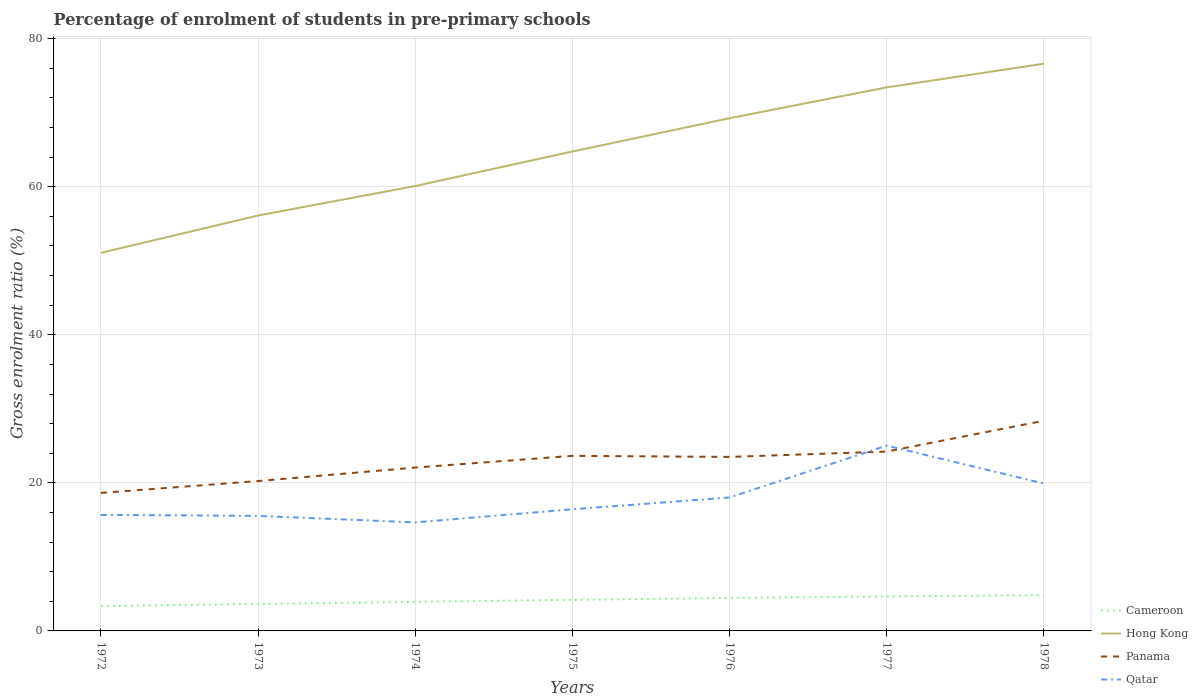How many different coloured lines are there?
Give a very brief answer. 4. Does the line corresponding to Cameroon intersect with the line corresponding to Qatar?
Your response must be concise. No. Is the number of lines equal to the number of legend labels?
Your answer should be compact. Yes. Across all years, what is the maximum percentage of students enrolled in pre-primary schools in Hong Kong?
Give a very brief answer. 51.07. In which year was the percentage of students enrolled in pre-primary schools in Panama maximum?
Your answer should be compact. 1972. What is the total percentage of students enrolled in pre-primary schools in Panama in the graph?
Your answer should be compact. -4.75. What is the difference between the highest and the second highest percentage of students enrolled in pre-primary schools in Cameroon?
Provide a short and direct response. 1.48. What is the difference between the highest and the lowest percentage of students enrolled in pre-primary schools in Qatar?
Ensure brevity in your answer.  3. How many lines are there?
Provide a succinct answer. 4. Are the values on the major ticks of Y-axis written in scientific E-notation?
Offer a terse response. No. Does the graph contain any zero values?
Your answer should be very brief. No. Does the graph contain grids?
Offer a terse response. Yes. How many legend labels are there?
Ensure brevity in your answer.  4. How are the legend labels stacked?
Your answer should be compact. Vertical. What is the title of the graph?
Your response must be concise. Percentage of enrolment of students in pre-primary schools. What is the label or title of the Y-axis?
Your response must be concise. Gross enrolment ratio (%). What is the Gross enrolment ratio (%) in Cameroon in 1972?
Make the answer very short. 3.35. What is the Gross enrolment ratio (%) of Hong Kong in 1972?
Offer a very short reply. 51.07. What is the Gross enrolment ratio (%) of Panama in 1972?
Give a very brief answer. 18.64. What is the Gross enrolment ratio (%) of Qatar in 1972?
Make the answer very short. 15.67. What is the Gross enrolment ratio (%) of Cameroon in 1973?
Your answer should be compact. 3.65. What is the Gross enrolment ratio (%) in Hong Kong in 1973?
Offer a terse response. 56.12. What is the Gross enrolment ratio (%) of Panama in 1973?
Keep it short and to the point. 20.25. What is the Gross enrolment ratio (%) in Qatar in 1973?
Your response must be concise. 15.54. What is the Gross enrolment ratio (%) in Cameroon in 1974?
Your answer should be compact. 3.93. What is the Gross enrolment ratio (%) of Hong Kong in 1974?
Make the answer very short. 60.1. What is the Gross enrolment ratio (%) of Panama in 1974?
Your response must be concise. 22.07. What is the Gross enrolment ratio (%) of Qatar in 1974?
Your answer should be compact. 14.66. What is the Gross enrolment ratio (%) in Cameroon in 1975?
Offer a very short reply. 4.19. What is the Gross enrolment ratio (%) of Hong Kong in 1975?
Your answer should be compact. 64.76. What is the Gross enrolment ratio (%) in Panama in 1975?
Provide a short and direct response. 23.65. What is the Gross enrolment ratio (%) of Qatar in 1975?
Ensure brevity in your answer.  16.43. What is the Gross enrolment ratio (%) in Cameroon in 1976?
Keep it short and to the point. 4.46. What is the Gross enrolment ratio (%) of Hong Kong in 1976?
Offer a very short reply. 69.26. What is the Gross enrolment ratio (%) of Panama in 1976?
Ensure brevity in your answer.  23.51. What is the Gross enrolment ratio (%) in Qatar in 1976?
Offer a terse response. 18.03. What is the Gross enrolment ratio (%) in Cameroon in 1977?
Your answer should be compact. 4.66. What is the Gross enrolment ratio (%) in Hong Kong in 1977?
Your answer should be compact. 73.43. What is the Gross enrolment ratio (%) of Panama in 1977?
Offer a terse response. 24.23. What is the Gross enrolment ratio (%) in Qatar in 1977?
Ensure brevity in your answer.  25.04. What is the Gross enrolment ratio (%) of Cameroon in 1978?
Provide a short and direct response. 4.83. What is the Gross enrolment ratio (%) in Hong Kong in 1978?
Make the answer very short. 76.62. What is the Gross enrolment ratio (%) of Panama in 1978?
Offer a very short reply. 28.4. What is the Gross enrolment ratio (%) in Qatar in 1978?
Offer a very short reply. 19.91. Across all years, what is the maximum Gross enrolment ratio (%) of Cameroon?
Your answer should be compact. 4.83. Across all years, what is the maximum Gross enrolment ratio (%) of Hong Kong?
Offer a terse response. 76.62. Across all years, what is the maximum Gross enrolment ratio (%) of Panama?
Offer a terse response. 28.4. Across all years, what is the maximum Gross enrolment ratio (%) in Qatar?
Your response must be concise. 25.04. Across all years, what is the minimum Gross enrolment ratio (%) of Cameroon?
Provide a short and direct response. 3.35. Across all years, what is the minimum Gross enrolment ratio (%) in Hong Kong?
Offer a very short reply. 51.07. Across all years, what is the minimum Gross enrolment ratio (%) of Panama?
Ensure brevity in your answer.  18.64. Across all years, what is the minimum Gross enrolment ratio (%) of Qatar?
Your response must be concise. 14.66. What is the total Gross enrolment ratio (%) of Cameroon in the graph?
Give a very brief answer. 29.07. What is the total Gross enrolment ratio (%) of Hong Kong in the graph?
Keep it short and to the point. 451.36. What is the total Gross enrolment ratio (%) of Panama in the graph?
Keep it short and to the point. 160.74. What is the total Gross enrolment ratio (%) of Qatar in the graph?
Provide a succinct answer. 125.28. What is the difference between the Gross enrolment ratio (%) in Cameroon in 1972 and that in 1973?
Give a very brief answer. -0.29. What is the difference between the Gross enrolment ratio (%) in Hong Kong in 1972 and that in 1973?
Offer a very short reply. -5.04. What is the difference between the Gross enrolment ratio (%) in Panama in 1972 and that in 1973?
Make the answer very short. -1.6. What is the difference between the Gross enrolment ratio (%) in Qatar in 1972 and that in 1973?
Provide a succinct answer. 0.13. What is the difference between the Gross enrolment ratio (%) in Cameroon in 1972 and that in 1974?
Offer a very short reply. -0.57. What is the difference between the Gross enrolment ratio (%) in Hong Kong in 1972 and that in 1974?
Give a very brief answer. -9.03. What is the difference between the Gross enrolment ratio (%) in Panama in 1972 and that in 1974?
Keep it short and to the point. -3.43. What is the difference between the Gross enrolment ratio (%) in Qatar in 1972 and that in 1974?
Provide a succinct answer. 1.01. What is the difference between the Gross enrolment ratio (%) in Cameroon in 1972 and that in 1975?
Ensure brevity in your answer.  -0.84. What is the difference between the Gross enrolment ratio (%) of Hong Kong in 1972 and that in 1975?
Offer a very short reply. -13.69. What is the difference between the Gross enrolment ratio (%) of Panama in 1972 and that in 1975?
Provide a succinct answer. -5.01. What is the difference between the Gross enrolment ratio (%) of Qatar in 1972 and that in 1975?
Offer a very short reply. -0.76. What is the difference between the Gross enrolment ratio (%) in Cameroon in 1972 and that in 1976?
Give a very brief answer. -1.11. What is the difference between the Gross enrolment ratio (%) of Hong Kong in 1972 and that in 1976?
Ensure brevity in your answer.  -18.19. What is the difference between the Gross enrolment ratio (%) in Panama in 1972 and that in 1976?
Ensure brevity in your answer.  -4.86. What is the difference between the Gross enrolment ratio (%) of Qatar in 1972 and that in 1976?
Your response must be concise. -2.36. What is the difference between the Gross enrolment ratio (%) in Cameroon in 1972 and that in 1977?
Provide a succinct answer. -1.31. What is the difference between the Gross enrolment ratio (%) in Hong Kong in 1972 and that in 1977?
Your response must be concise. -22.36. What is the difference between the Gross enrolment ratio (%) in Panama in 1972 and that in 1977?
Offer a very short reply. -5.59. What is the difference between the Gross enrolment ratio (%) of Qatar in 1972 and that in 1977?
Give a very brief answer. -9.37. What is the difference between the Gross enrolment ratio (%) of Cameroon in 1972 and that in 1978?
Provide a short and direct response. -1.48. What is the difference between the Gross enrolment ratio (%) in Hong Kong in 1972 and that in 1978?
Provide a succinct answer. -25.55. What is the difference between the Gross enrolment ratio (%) in Panama in 1972 and that in 1978?
Your response must be concise. -9.75. What is the difference between the Gross enrolment ratio (%) of Qatar in 1972 and that in 1978?
Provide a succinct answer. -4.24. What is the difference between the Gross enrolment ratio (%) of Cameroon in 1973 and that in 1974?
Your answer should be very brief. -0.28. What is the difference between the Gross enrolment ratio (%) of Hong Kong in 1973 and that in 1974?
Give a very brief answer. -3.98. What is the difference between the Gross enrolment ratio (%) of Panama in 1973 and that in 1974?
Keep it short and to the point. -1.82. What is the difference between the Gross enrolment ratio (%) in Qatar in 1973 and that in 1974?
Your answer should be very brief. 0.88. What is the difference between the Gross enrolment ratio (%) in Cameroon in 1973 and that in 1975?
Your response must be concise. -0.55. What is the difference between the Gross enrolment ratio (%) in Hong Kong in 1973 and that in 1975?
Offer a terse response. -8.65. What is the difference between the Gross enrolment ratio (%) of Panama in 1973 and that in 1975?
Your answer should be compact. -3.4. What is the difference between the Gross enrolment ratio (%) of Qatar in 1973 and that in 1975?
Keep it short and to the point. -0.89. What is the difference between the Gross enrolment ratio (%) of Cameroon in 1973 and that in 1976?
Your response must be concise. -0.81. What is the difference between the Gross enrolment ratio (%) of Hong Kong in 1973 and that in 1976?
Your response must be concise. -13.14. What is the difference between the Gross enrolment ratio (%) of Panama in 1973 and that in 1976?
Your answer should be compact. -3.26. What is the difference between the Gross enrolment ratio (%) in Qatar in 1973 and that in 1976?
Your answer should be compact. -2.49. What is the difference between the Gross enrolment ratio (%) in Cameroon in 1973 and that in 1977?
Offer a terse response. -1.01. What is the difference between the Gross enrolment ratio (%) of Hong Kong in 1973 and that in 1977?
Offer a very short reply. -17.31. What is the difference between the Gross enrolment ratio (%) of Panama in 1973 and that in 1977?
Your response must be concise. -3.98. What is the difference between the Gross enrolment ratio (%) in Qatar in 1973 and that in 1977?
Your answer should be very brief. -9.5. What is the difference between the Gross enrolment ratio (%) in Cameroon in 1973 and that in 1978?
Provide a succinct answer. -1.19. What is the difference between the Gross enrolment ratio (%) in Hong Kong in 1973 and that in 1978?
Your answer should be compact. -20.51. What is the difference between the Gross enrolment ratio (%) of Panama in 1973 and that in 1978?
Provide a short and direct response. -8.15. What is the difference between the Gross enrolment ratio (%) of Qatar in 1973 and that in 1978?
Your answer should be compact. -4.37. What is the difference between the Gross enrolment ratio (%) in Cameroon in 1974 and that in 1975?
Provide a succinct answer. -0.27. What is the difference between the Gross enrolment ratio (%) of Hong Kong in 1974 and that in 1975?
Provide a short and direct response. -4.67. What is the difference between the Gross enrolment ratio (%) in Panama in 1974 and that in 1975?
Your answer should be compact. -1.58. What is the difference between the Gross enrolment ratio (%) in Qatar in 1974 and that in 1975?
Offer a very short reply. -1.77. What is the difference between the Gross enrolment ratio (%) in Cameroon in 1974 and that in 1976?
Your answer should be compact. -0.53. What is the difference between the Gross enrolment ratio (%) in Hong Kong in 1974 and that in 1976?
Offer a very short reply. -9.16. What is the difference between the Gross enrolment ratio (%) in Panama in 1974 and that in 1976?
Offer a terse response. -1.44. What is the difference between the Gross enrolment ratio (%) of Qatar in 1974 and that in 1976?
Your response must be concise. -3.37. What is the difference between the Gross enrolment ratio (%) in Cameroon in 1974 and that in 1977?
Your answer should be very brief. -0.73. What is the difference between the Gross enrolment ratio (%) of Hong Kong in 1974 and that in 1977?
Make the answer very short. -13.33. What is the difference between the Gross enrolment ratio (%) in Panama in 1974 and that in 1977?
Your answer should be very brief. -2.16. What is the difference between the Gross enrolment ratio (%) of Qatar in 1974 and that in 1977?
Give a very brief answer. -10.38. What is the difference between the Gross enrolment ratio (%) of Cameroon in 1974 and that in 1978?
Provide a short and direct response. -0.91. What is the difference between the Gross enrolment ratio (%) of Hong Kong in 1974 and that in 1978?
Give a very brief answer. -16.53. What is the difference between the Gross enrolment ratio (%) of Panama in 1974 and that in 1978?
Give a very brief answer. -6.33. What is the difference between the Gross enrolment ratio (%) of Qatar in 1974 and that in 1978?
Keep it short and to the point. -5.25. What is the difference between the Gross enrolment ratio (%) of Cameroon in 1975 and that in 1976?
Your answer should be very brief. -0.26. What is the difference between the Gross enrolment ratio (%) in Hong Kong in 1975 and that in 1976?
Provide a short and direct response. -4.5. What is the difference between the Gross enrolment ratio (%) of Panama in 1975 and that in 1976?
Offer a very short reply. 0.14. What is the difference between the Gross enrolment ratio (%) of Qatar in 1975 and that in 1976?
Provide a succinct answer. -1.6. What is the difference between the Gross enrolment ratio (%) of Cameroon in 1975 and that in 1977?
Make the answer very short. -0.46. What is the difference between the Gross enrolment ratio (%) in Hong Kong in 1975 and that in 1977?
Offer a very short reply. -8.67. What is the difference between the Gross enrolment ratio (%) in Panama in 1975 and that in 1977?
Ensure brevity in your answer.  -0.58. What is the difference between the Gross enrolment ratio (%) in Qatar in 1975 and that in 1977?
Your answer should be very brief. -8.61. What is the difference between the Gross enrolment ratio (%) of Cameroon in 1975 and that in 1978?
Keep it short and to the point. -0.64. What is the difference between the Gross enrolment ratio (%) of Hong Kong in 1975 and that in 1978?
Ensure brevity in your answer.  -11.86. What is the difference between the Gross enrolment ratio (%) of Panama in 1975 and that in 1978?
Your answer should be very brief. -4.75. What is the difference between the Gross enrolment ratio (%) of Qatar in 1975 and that in 1978?
Keep it short and to the point. -3.48. What is the difference between the Gross enrolment ratio (%) in Cameroon in 1976 and that in 1977?
Make the answer very short. -0.2. What is the difference between the Gross enrolment ratio (%) in Hong Kong in 1976 and that in 1977?
Ensure brevity in your answer.  -4.17. What is the difference between the Gross enrolment ratio (%) in Panama in 1976 and that in 1977?
Provide a succinct answer. -0.72. What is the difference between the Gross enrolment ratio (%) of Qatar in 1976 and that in 1977?
Make the answer very short. -7.01. What is the difference between the Gross enrolment ratio (%) of Cameroon in 1976 and that in 1978?
Make the answer very short. -0.37. What is the difference between the Gross enrolment ratio (%) of Hong Kong in 1976 and that in 1978?
Your response must be concise. -7.36. What is the difference between the Gross enrolment ratio (%) in Panama in 1976 and that in 1978?
Your answer should be very brief. -4.89. What is the difference between the Gross enrolment ratio (%) of Qatar in 1976 and that in 1978?
Make the answer very short. -1.88. What is the difference between the Gross enrolment ratio (%) of Cameroon in 1977 and that in 1978?
Give a very brief answer. -0.17. What is the difference between the Gross enrolment ratio (%) in Hong Kong in 1977 and that in 1978?
Your answer should be very brief. -3.19. What is the difference between the Gross enrolment ratio (%) in Panama in 1977 and that in 1978?
Offer a terse response. -4.17. What is the difference between the Gross enrolment ratio (%) in Qatar in 1977 and that in 1978?
Your answer should be compact. 5.13. What is the difference between the Gross enrolment ratio (%) of Cameroon in 1972 and the Gross enrolment ratio (%) of Hong Kong in 1973?
Offer a terse response. -52.76. What is the difference between the Gross enrolment ratio (%) in Cameroon in 1972 and the Gross enrolment ratio (%) in Panama in 1973?
Provide a succinct answer. -16.89. What is the difference between the Gross enrolment ratio (%) in Cameroon in 1972 and the Gross enrolment ratio (%) in Qatar in 1973?
Your answer should be very brief. -12.19. What is the difference between the Gross enrolment ratio (%) of Hong Kong in 1972 and the Gross enrolment ratio (%) of Panama in 1973?
Your answer should be compact. 30.82. What is the difference between the Gross enrolment ratio (%) in Hong Kong in 1972 and the Gross enrolment ratio (%) in Qatar in 1973?
Your response must be concise. 35.53. What is the difference between the Gross enrolment ratio (%) of Panama in 1972 and the Gross enrolment ratio (%) of Qatar in 1973?
Ensure brevity in your answer.  3.1. What is the difference between the Gross enrolment ratio (%) of Cameroon in 1972 and the Gross enrolment ratio (%) of Hong Kong in 1974?
Offer a very short reply. -56.75. What is the difference between the Gross enrolment ratio (%) in Cameroon in 1972 and the Gross enrolment ratio (%) in Panama in 1974?
Give a very brief answer. -18.72. What is the difference between the Gross enrolment ratio (%) in Cameroon in 1972 and the Gross enrolment ratio (%) in Qatar in 1974?
Your answer should be compact. -11.31. What is the difference between the Gross enrolment ratio (%) in Hong Kong in 1972 and the Gross enrolment ratio (%) in Panama in 1974?
Offer a terse response. 29. What is the difference between the Gross enrolment ratio (%) in Hong Kong in 1972 and the Gross enrolment ratio (%) in Qatar in 1974?
Your answer should be very brief. 36.41. What is the difference between the Gross enrolment ratio (%) of Panama in 1972 and the Gross enrolment ratio (%) of Qatar in 1974?
Keep it short and to the point. 3.98. What is the difference between the Gross enrolment ratio (%) of Cameroon in 1972 and the Gross enrolment ratio (%) of Hong Kong in 1975?
Ensure brevity in your answer.  -61.41. What is the difference between the Gross enrolment ratio (%) of Cameroon in 1972 and the Gross enrolment ratio (%) of Panama in 1975?
Provide a short and direct response. -20.3. What is the difference between the Gross enrolment ratio (%) in Cameroon in 1972 and the Gross enrolment ratio (%) in Qatar in 1975?
Your answer should be very brief. -13.08. What is the difference between the Gross enrolment ratio (%) in Hong Kong in 1972 and the Gross enrolment ratio (%) in Panama in 1975?
Keep it short and to the point. 27.42. What is the difference between the Gross enrolment ratio (%) in Hong Kong in 1972 and the Gross enrolment ratio (%) in Qatar in 1975?
Make the answer very short. 34.64. What is the difference between the Gross enrolment ratio (%) in Panama in 1972 and the Gross enrolment ratio (%) in Qatar in 1975?
Your answer should be compact. 2.21. What is the difference between the Gross enrolment ratio (%) in Cameroon in 1972 and the Gross enrolment ratio (%) in Hong Kong in 1976?
Provide a short and direct response. -65.91. What is the difference between the Gross enrolment ratio (%) in Cameroon in 1972 and the Gross enrolment ratio (%) in Panama in 1976?
Your answer should be very brief. -20.15. What is the difference between the Gross enrolment ratio (%) of Cameroon in 1972 and the Gross enrolment ratio (%) of Qatar in 1976?
Offer a very short reply. -14.68. What is the difference between the Gross enrolment ratio (%) of Hong Kong in 1972 and the Gross enrolment ratio (%) of Panama in 1976?
Offer a terse response. 27.57. What is the difference between the Gross enrolment ratio (%) in Hong Kong in 1972 and the Gross enrolment ratio (%) in Qatar in 1976?
Your answer should be compact. 33.04. What is the difference between the Gross enrolment ratio (%) in Panama in 1972 and the Gross enrolment ratio (%) in Qatar in 1976?
Your answer should be very brief. 0.62. What is the difference between the Gross enrolment ratio (%) in Cameroon in 1972 and the Gross enrolment ratio (%) in Hong Kong in 1977?
Your response must be concise. -70.08. What is the difference between the Gross enrolment ratio (%) of Cameroon in 1972 and the Gross enrolment ratio (%) of Panama in 1977?
Offer a very short reply. -20.88. What is the difference between the Gross enrolment ratio (%) in Cameroon in 1972 and the Gross enrolment ratio (%) in Qatar in 1977?
Provide a short and direct response. -21.69. What is the difference between the Gross enrolment ratio (%) of Hong Kong in 1972 and the Gross enrolment ratio (%) of Panama in 1977?
Offer a terse response. 26.84. What is the difference between the Gross enrolment ratio (%) of Hong Kong in 1972 and the Gross enrolment ratio (%) of Qatar in 1977?
Offer a very short reply. 26.03. What is the difference between the Gross enrolment ratio (%) of Panama in 1972 and the Gross enrolment ratio (%) of Qatar in 1977?
Give a very brief answer. -6.39. What is the difference between the Gross enrolment ratio (%) in Cameroon in 1972 and the Gross enrolment ratio (%) in Hong Kong in 1978?
Provide a short and direct response. -73.27. What is the difference between the Gross enrolment ratio (%) in Cameroon in 1972 and the Gross enrolment ratio (%) in Panama in 1978?
Provide a short and direct response. -25.05. What is the difference between the Gross enrolment ratio (%) of Cameroon in 1972 and the Gross enrolment ratio (%) of Qatar in 1978?
Provide a short and direct response. -16.56. What is the difference between the Gross enrolment ratio (%) in Hong Kong in 1972 and the Gross enrolment ratio (%) in Panama in 1978?
Make the answer very short. 22.67. What is the difference between the Gross enrolment ratio (%) of Hong Kong in 1972 and the Gross enrolment ratio (%) of Qatar in 1978?
Provide a succinct answer. 31.16. What is the difference between the Gross enrolment ratio (%) of Panama in 1972 and the Gross enrolment ratio (%) of Qatar in 1978?
Keep it short and to the point. -1.27. What is the difference between the Gross enrolment ratio (%) in Cameroon in 1973 and the Gross enrolment ratio (%) in Hong Kong in 1974?
Your answer should be compact. -56.45. What is the difference between the Gross enrolment ratio (%) of Cameroon in 1973 and the Gross enrolment ratio (%) of Panama in 1974?
Your response must be concise. -18.42. What is the difference between the Gross enrolment ratio (%) in Cameroon in 1973 and the Gross enrolment ratio (%) in Qatar in 1974?
Your answer should be very brief. -11.01. What is the difference between the Gross enrolment ratio (%) of Hong Kong in 1973 and the Gross enrolment ratio (%) of Panama in 1974?
Your response must be concise. 34.05. What is the difference between the Gross enrolment ratio (%) in Hong Kong in 1973 and the Gross enrolment ratio (%) in Qatar in 1974?
Ensure brevity in your answer.  41.45. What is the difference between the Gross enrolment ratio (%) of Panama in 1973 and the Gross enrolment ratio (%) of Qatar in 1974?
Make the answer very short. 5.59. What is the difference between the Gross enrolment ratio (%) in Cameroon in 1973 and the Gross enrolment ratio (%) in Hong Kong in 1975?
Provide a short and direct response. -61.12. What is the difference between the Gross enrolment ratio (%) in Cameroon in 1973 and the Gross enrolment ratio (%) in Panama in 1975?
Your answer should be compact. -20. What is the difference between the Gross enrolment ratio (%) of Cameroon in 1973 and the Gross enrolment ratio (%) of Qatar in 1975?
Your answer should be compact. -12.79. What is the difference between the Gross enrolment ratio (%) of Hong Kong in 1973 and the Gross enrolment ratio (%) of Panama in 1975?
Offer a terse response. 32.47. What is the difference between the Gross enrolment ratio (%) of Hong Kong in 1973 and the Gross enrolment ratio (%) of Qatar in 1975?
Keep it short and to the point. 39.68. What is the difference between the Gross enrolment ratio (%) of Panama in 1973 and the Gross enrolment ratio (%) of Qatar in 1975?
Offer a very short reply. 3.81. What is the difference between the Gross enrolment ratio (%) in Cameroon in 1973 and the Gross enrolment ratio (%) in Hong Kong in 1976?
Ensure brevity in your answer.  -65.61. What is the difference between the Gross enrolment ratio (%) in Cameroon in 1973 and the Gross enrolment ratio (%) in Panama in 1976?
Offer a terse response. -19.86. What is the difference between the Gross enrolment ratio (%) in Cameroon in 1973 and the Gross enrolment ratio (%) in Qatar in 1976?
Make the answer very short. -14.38. What is the difference between the Gross enrolment ratio (%) in Hong Kong in 1973 and the Gross enrolment ratio (%) in Panama in 1976?
Provide a succinct answer. 32.61. What is the difference between the Gross enrolment ratio (%) of Hong Kong in 1973 and the Gross enrolment ratio (%) of Qatar in 1976?
Offer a very short reply. 38.09. What is the difference between the Gross enrolment ratio (%) in Panama in 1973 and the Gross enrolment ratio (%) in Qatar in 1976?
Make the answer very short. 2.22. What is the difference between the Gross enrolment ratio (%) in Cameroon in 1973 and the Gross enrolment ratio (%) in Hong Kong in 1977?
Provide a short and direct response. -69.78. What is the difference between the Gross enrolment ratio (%) in Cameroon in 1973 and the Gross enrolment ratio (%) in Panama in 1977?
Offer a very short reply. -20.58. What is the difference between the Gross enrolment ratio (%) of Cameroon in 1973 and the Gross enrolment ratio (%) of Qatar in 1977?
Your answer should be compact. -21.39. What is the difference between the Gross enrolment ratio (%) in Hong Kong in 1973 and the Gross enrolment ratio (%) in Panama in 1977?
Give a very brief answer. 31.89. What is the difference between the Gross enrolment ratio (%) in Hong Kong in 1973 and the Gross enrolment ratio (%) in Qatar in 1977?
Offer a terse response. 31.08. What is the difference between the Gross enrolment ratio (%) in Panama in 1973 and the Gross enrolment ratio (%) in Qatar in 1977?
Offer a very short reply. -4.79. What is the difference between the Gross enrolment ratio (%) of Cameroon in 1973 and the Gross enrolment ratio (%) of Hong Kong in 1978?
Ensure brevity in your answer.  -72.98. What is the difference between the Gross enrolment ratio (%) in Cameroon in 1973 and the Gross enrolment ratio (%) in Panama in 1978?
Make the answer very short. -24.75. What is the difference between the Gross enrolment ratio (%) in Cameroon in 1973 and the Gross enrolment ratio (%) in Qatar in 1978?
Offer a terse response. -16.27. What is the difference between the Gross enrolment ratio (%) in Hong Kong in 1973 and the Gross enrolment ratio (%) in Panama in 1978?
Keep it short and to the point. 27.72. What is the difference between the Gross enrolment ratio (%) of Hong Kong in 1973 and the Gross enrolment ratio (%) of Qatar in 1978?
Your response must be concise. 36.2. What is the difference between the Gross enrolment ratio (%) of Panama in 1973 and the Gross enrolment ratio (%) of Qatar in 1978?
Provide a succinct answer. 0.33. What is the difference between the Gross enrolment ratio (%) of Cameroon in 1974 and the Gross enrolment ratio (%) of Hong Kong in 1975?
Give a very brief answer. -60.84. What is the difference between the Gross enrolment ratio (%) of Cameroon in 1974 and the Gross enrolment ratio (%) of Panama in 1975?
Offer a terse response. -19.72. What is the difference between the Gross enrolment ratio (%) in Cameroon in 1974 and the Gross enrolment ratio (%) in Qatar in 1975?
Your answer should be compact. -12.51. What is the difference between the Gross enrolment ratio (%) in Hong Kong in 1974 and the Gross enrolment ratio (%) in Panama in 1975?
Keep it short and to the point. 36.45. What is the difference between the Gross enrolment ratio (%) of Hong Kong in 1974 and the Gross enrolment ratio (%) of Qatar in 1975?
Your response must be concise. 43.67. What is the difference between the Gross enrolment ratio (%) in Panama in 1974 and the Gross enrolment ratio (%) in Qatar in 1975?
Your answer should be very brief. 5.64. What is the difference between the Gross enrolment ratio (%) in Cameroon in 1974 and the Gross enrolment ratio (%) in Hong Kong in 1976?
Keep it short and to the point. -65.33. What is the difference between the Gross enrolment ratio (%) in Cameroon in 1974 and the Gross enrolment ratio (%) in Panama in 1976?
Provide a short and direct response. -19.58. What is the difference between the Gross enrolment ratio (%) of Cameroon in 1974 and the Gross enrolment ratio (%) of Qatar in 1976?
Ensure brevity in your answer.  -14.1. What is the difference between the Gross enrolment ratio (%) in Hong Kong in 1974 and the Gross enrolment ratio (%) in Panama in 1976?
Give a very brief answer. 36.59. What is the difference between the Gross enrolment ratio (%) of Hong Kong in 1974 and the Gross enrolment ratio (%) of Qatar in 1976?
Provide a succinct answer. 42.07. What is the difference between the Gross enrolment ratio (%) in Panama in 1974 and the Gross enrolment ratio (%) in Qatar in 1976?
Provide a short and direct response. 4.04. What is the difference between the Gross enrolment ratio (%) of Cameroon in 1974 and the Gross enrolment ratio (%) of Hong Kong in 1977?
Provide a short and direct response. -69.5. What is the difference between the Gross enrolment ratio (%) of Cameroon in 1974 and the Gross enrolment ratio (%) of Panama in 1977?
Your response must be concise. -20.3. What is the difference between the Gross enrolment ratio (%) in Cameroon in 1974 and the Gross enrolment ratio (%) in Qatar in 1977?
Provide a succinct answer. -21.11. What is the difference between the Gross enrolment ratio (%) in Hong Kong in 1974 and the Gross enrolment ratio (%) in Panama in 1977?
Your answer should be very brief. 35.87. What is the difference between the Gross enrolment ratio (%) in Hong Kong in 1974 and the Gross enrolment ratio (%) in Qatar in 1977?
Offer a very short reply. 35.06. What is the difference between the Gross enrolment ratio (%) in Panama in 1974 and the Gross enrolment ratio (%) in Qatar in 1977?
Provide a succinct answer. -2.97. What is the difference between the Gross enrolment ratio (%) of Cameroon in 1974 and the Gross enrolment ratio (%) of Hong Kong in 1978?
Your response must be concise. -72.7. What is the difference between the Gross enrolment ratio (%) in Cameroon in 1974 and the Gross enrolment ratio (%) in Panama in 1978?
Provide a short and direct response. -24.47. What is the difference between the Gross enrolment ratio (%) in Cameroon in 1974 and the Gross enrolment ratio (%) in Qatar in 1978?
Your answer should be very brief. -15.99. What is the difference between the Gross enrolment ratio (%) of Hong Kong in 1974 and the Gross enrolment ratio (%) of Panama in 1978?
Make the answer very short. 31.7. What is the difference between the Gross enrolment ratio (%) of Hong Kong in 1974 and the Gross enrolment ratio (%) of Qatar in 1978?
Your answer should be very brief. 40.19. What is the difference between the Gross enrolment ratio (%) of Panama in 1974 and the Gross enrolment ratio (%) of Qatar in 1978?
Give a very brief answer. 2.16. What is the difference between the Gross enrolment ratio (%) of Cameroon in 1975 and the Gross enrolment ratio (%) of Hong Kong in 1976?
Your answer should be compact. -65.07. What is the difference between the Gross enrolment ratio (%) of Cameroon in 1975 and the Gross enrolment ratio (%) of Panama in 1976?
Give a very brief answer. -19.31. What is the difference between the Gross enrolment ratio (%) of Cameroon in 1975 and the Gross enrolment ratio (%) of Qatar in 1976?
Give a very brief answer. -13.83. What is the difference between the Gross enrolment ratio (%) of Hong Kong in 1975 and the Gross enrolment ratio (%) of Panama in 1976?
Give a very brief answer. 41.26. What is the difference between the Gross enrolment ratio (%) in Hong Kong in 1975 and the Gross enrolment ratio (%) in Qatar in 1976?
Make the answer very short. 46.74. What is the difference between the Gross enrolment ratio (%) of Panama in 1975 and the Gross enrolment ratio (%) of Qatar in 1976?
Make the answer very short. 5.62. What is the difference between the Gross enrolment ratio (%) of Cameroon in 1975 and the Gross enrolment ratio (%) of Hong Kong in 1977?
Your response must be concise. -69.23. What is the difference between the Gross enrolment ratio (%) in Cameroon in 1975 and the Gross enrolment ratio (%) in Panama in 1977?
Your response must be concise. -20.04. What is the difference between the Gross enrolment ratio (%) of Cameroon in 1975 and the Gross enrolment ratio (%) of Qatar in 1977?
Your response must be concise. -20.84. What is the difference between the Gross enrolment ratio (%) in Hong Kong in 1975 and the Gross enrolment ratio (%) in Panama in 1977?
Provide a succinct answer. 40.53. What is the difference between the Gross enrolment ratio (%) in Hong Kong in 1975 and the Gross enrolment ratio (%) in Qatar in 1977?
Make the answer very short. 39.73. What is the difference between the Gross enrolment ratio (%) of Panama in 1975 and the Gross enrolment ratio (%) of Qatar in 1977?
Give a very brief answer. -1.39. What is the difference between the Gross enrolment ratio (%) of Cameroon in 1975 and the Gross enrolment ratio (%) of Hong Kong in 1978?
Your answer should be compact. -72.43. What is the difference between the Gross enrolment ratio (%) in Cameroon in 1975 and the Gross enrolment ratio (%) in Panama in 1978?
Your response must be concise. -24.2. What is the difference between the Gross enrolment ratio (%) of Cameroon in 1975 and the Gross enrolment ratio (%) of Qatar in 1978?
Keep it short and to the point. -15.72. What is the difference between the Gross enrolment ratio (%) of Hong Kong in 1975 and the Gross enrolment ratio (%) of Panama in 1978?
Provide a succinct answer. 36.37. What is the difference between the Gross enrolment ratio (%) of Hong Kong in 1975 and the Gross enrolment ratio (%) of Qatar in 1978?
Ensure brevity in your answer.  44.85. What is the difference between the Gross enrolment ratio (%) in Panama in 1975 and the Gross enrolment ratio (%) in Qatar in 1978?
Ensure brevity in your answer.  3.74. What is the difference between the Gross enrolment ratio (%) in Cameroon in 1976 and the Gross enrolment ratio (%) in Hong Kong in 1977?
Provide a succinct answer. -68.97. What is the difference between the Gross enrolment ratio (%) in Cameroon in 1976 and the Gross enrolment ratio (%) in Panama in 1977?
Give a very brief answer. -19.77. What is the difference between the Gross enrolment ratio (%) in Cameroon in 1976 and the Gross enrolment ratio (%) in Qatar in 1977?
Ensure brevity in your answer.  -20.58. What is the difference between the Gross enrolment ratio (%) of Hong Kong in 1976 and the Gross enrolment ratio (%) of Panama in 1977?
Your answer should be compact. 45.03. What is the difference between the Gross enrolment ratio (%) of Hong Kong in 1976 and the Gross enrolment ratio (%) of Qatar in 1977?
Your response must be concise. 44.22. What is the difference between the Gross enrolment ratio (%) in Panama in 1976 and the Gross enrolment ratio (%) in Qatar in 1977?
Give a very brief answer. -1.53. What is the difference between the Gross enrolment ratio (%) of Cameroon in 1976 and the Gross enrolment ratio (%) of Hong Kong in 1978?
Provide a succinct answer. -72.17. What is the difference between the Gross enrolment ratio (%) in Cameroon in 1976 and the Gross enrolment ratio (%) in Panama in 1978?
Give a very brief answer. -23.94. What is the difference between the Gross enrolment ratio (%) in Cameroon in 1976 and the Gross enrolment ratio (%) in Qatar in 1978?
Give a very brief answer. -15.45. What is the difference between the Gross enrolment ratio (%) in Hong Kong in 1976 and the Gross enrolment ratio (%) in Panama in 1978?
Keep it short and to the point. 40.86. What is the difference between the Gross enrolment ratio (%) of Hong Kong in 1976 and the Gross enrolment ratio (%) of Qatar in 1978?
Provide a succinct answer. 49.35. What is the difference between the Gross enrolment ratio (%) in Panama in 1976 and the Gross enrolment ratio (%) in Qatar in 1978?
Offer a terse response. 3.59. What is the difference between the Gross enrolment ratio (%) in Cameroon in 1977 and the Gross enrolment ratio (%) in Hong Kong in 1978?
Provide a succinct answer. -71.96. What is the difference between the Gross enrolment ratio (%) of Cameroon in 1977 and the Gross enrolment ratio (%) of Panama in 1978?
Provide a succinct answer. -23.74. What is the difference between the Gross enrolment ratio (%) in Cameroon in 1977 and the Gross enrolment ratio (%) in Qatar in 1978?
Offer a very short reply. -15.25. What is the difference between the Gross enrolment ratio (%) of Hong Kong in 1977 and the Gross enrolment ratio (%) of Panama in 1978?
Your answer should be very brief. 45.03. What is the difference between the Gross enrolment ratio (%) in Hong Kong in 1977 and the Gross enrolment ratio (%) in Qatar in 1978?
Your response must be concise. 53.52. What is the difference between the Gross enrolment ratio (%) of Panama in 1977 and the Gross enrolment ratio (%) of Qatar in 1978?
Offer a very short reply. 4.32. What is the average Gross enrolment ratio (%) of Cameroon per year?
Provide a succinct answer. 4.15. What is the average Gross enrolment ratio (%) in Hong Kong per year?
Ensure brevity in your answer.  64.48. What is the average Gross enrolment ratio (%) of Panama per year?
Offer a terse response. 22.96. What is the average Gross enrolment ratio (%) in Qatar per year?
Provide a short and direct response. 17.9. In the year 1972, what is the difference between the Gross enrolment ratio (%) in Cameroon and Gross enrolment ratio (%) in Hong Kong?
Ensure brevity in your answer.  -47.72. In the year 1972, what is the difference between the Gross enrolment ratio (%) of Cameroon and Gross enrolment ratio (%) of Panama?
Ensure brevity in your answer.  -15.29. In the year 1972, what is the difference between the Gross enrolment ratio (%) of Cameroon and Gross enrolment ratio (%) of Qatar?
Make the answer very short. -12.32. In the year 1972, what is the difference between the Gross enrolment ratio (%) of Hong Kong and Gross enrolment ratio (%) of Panama?
Your response must be concise. 32.43. In the year 1972, what is the difference between the Gross enrolment ratio (%) of Hong Kong and Gross enrolment ratio (%) of Qatar?
Offer a very short reply. 35.4. In the year 1972, what is the difference between the Gross enrolment ratio (%) of Panama and Gross enrolment ratio (%) of Qatar?
Offer a very short reply. 2.98. In the year 1973, what is the difference between the Gross enrolment ratio (%) of Cameroon and Gross enrolment ratio (%) of Hong Kong?
Your response must be concise. -52.47. In the year 1973, what is the difference between the Gross enrolment ratio (%) of Cameroon and Gross enrolment ratio (%) of Panama?
Offer a very short reply. -16.6. In the year 1973, what is the difference between the Gross enrolment ratio (%) in Cameroon and Gross enrolment ratio (%) in Qatar?
Keep it short and to the point. -11.89. In the year 1973, what is the difference between the Gross enrolment ratio (%) of Hong Kong and Gross enrolment ratio (%) of Panama?
Give a very brief answer. 35.87. In the year 1973, what is the difference between the Gross enrolment ratio (%) of Hong Kong and Gross enrolment ratio (%) of Qatar?
Offer a terse response. 40.58. In the year 1973, what is the difference between the Gross enrolment ratio (%) in Panama and Gross enrolment ratio (%) in Qatar?
Offer a very short reply. 4.71. In the year 1974, what is the difference between the Gross enrolment ratio (%) in Cameroon and Gross enrolment ratio (%) in Hong Kong?
Provide a short and direct response. -56.17. In the year 1974, what is the difference between the Gross enrolment ratio (%) in Cameroon and Gross enrolment ratio (%) in Panama?
Give a very brief answer. -18.14. In the year 1974, what is the difference between the Gross enrolment ratio (%) in Cameroon and Gross enrolment ratio (%) in Qatar?
Offer a very short reply. -10.74. In the year 1974, what is the difference between the Gross enrolment ratio (%) in Hong Kong and Gross enrolment ratio (%) in Panama?
Offer a terse response. 38.03. In the year 1974, what is the difference between the Gross enrolment ratio (%) of Hong Kong and Gross enrolment ratio (%) of Qatar?
Your answer should be very brief. 45.44. In the year 1974, what is the difference between the Gross enrolment ratio (%) of Panama and Gross enrolment ratio (%) of Qatar?
Your answer should be compact. 7.41. In the year 1975, what is the difference between the Gross enrolment ratio (%) of Cameroon and Gross enrolment ratio (%) of Hong Kong?
Ensure brevity in your answer.  -60.57. In the year 1975, what is the difference between the Gross enrolment ratio (%) of Cameroon and Gross enrolment ratio (%) of Panama?
Your answer should be very brief. -19.46. In the year 1975, what is the difference between the Gross enrolment ratio (%) of Cameroon and Gross enrolment ratio (%) of Qatar?
Offer a very short reply. -12.24. In the year 1975, what is the difference between the Gross enrolment ratio (%) of Hong Kong and Gross enrolment ratio (%) of Panama?
Your answer should be very brief. 41.11. In the year 1975, what is the difference between the Gross enrolment ratio (%) of Hong Kong and Gross enrolment ratio (%) of Qatar?
Provide a succinct answer. 48.33. In the year 1975, what is the difference between the Gross enrolment ratio (%) in Panama and Gross enrolment ratio (%) in Qatar?
Provide a succinct answer. 7.22. In the year 1976, what is the difference between the Gross enrolment ratio (%) in Cameroon and Gross enrolment ratio (%) in Hong Kong?
Your answer should be very brief. -64.8. In the year 1976, what is the difference between the Gross enrolment ratio (%) of Cameroon and Gross enrolment ratio (%) of Panama?
Give a very brief answer. -19.05. In the year 1976, what is the difference between the Gross enrolment ratio (%) of Cameroon and Gross enrolment ratio (%) of Qatar?
Your answer should be compact. -13.57. In the year 1976, what is the difference between the Gross enrolment ratio (%) in Hong Kong and Gross enrolment ratio (%) in Panama?
Give a very brief answer. 45.75. In the year 1976, what is the difference between the Gross enrolment ratio (%) in Hong Kong and Gross enrolment ratio (%) in Qatar?
Your answer should be compact. 51.23. In the year 1976, what is the difference between the Gross enrolment ratio (%) in Panama and Gross enrolment ratio (%) in Qatar?
Your answer should be very brief. 5.48. In the year 1977, what is the difference between the Gross enrolment ratio (%) in Cameroon and Gross enrolment ratio (%) in Hong Kong?
Your answer should be very brief. -68.77. In the year 1977, what is the difference between the Gross enrolment ratio (%) in Cameroon and Gross enrolment ratio (%) in Panama?
Offer a very short reply. -19.57. In the year 1977, what is the difference between the Gross enrolment ratio (%) in Cameroon and Gross enrolment ratio (%) in Qatar?
Keep it short and to the point. -20.38. In the year 1977, what is the difference between the Gross enrolment ratio (%) of Hong Kong and Gross enrolment ratio (%) of Panama?
Your response must be concise. 49.2. In the year 1977, what is the difference between the Gross enrolment ratio (%) of Hong Kong and Gross enrolment ratio (%) of Qatar?
Offer a terse response. 48.39. In the year 1977, what is the difference between the Gross enrolment ratio (%) of Panama and Gross enrolment ratio (%) of Qatar?
Keep it short and to the point. -0.81. In the year 1978, what is the difference between the Gross enrolment ratio (%) in Cameroon and Gross enrolment ratio (%) in Hong Kong?
Provide a short and direct response. -71.79. In the year 1978, what is the difference between the Gross enrolment ratio (%) of Cameroon and Gross enrolment ratio (%) of Panama?
Ensure brevity in your answer.  -23.57. In the year 1978, what is the difference between the Gross enrolment ratio (%) in Cameroon and Gross enrolment ratio (%) in Qatar?
Keep it short and to the point. -15.08. In the year 1978, what is the difference between the Gross enrolment ratio (%) in Hong Kong and Gross enrolment ratio (%) in Panama?
Provide a short and direct response. 48.23. In the year 1978, what is the difference between the Gross enrolment ratio (%) in Hong Kong and Gross enrolment ratio (%) in Qatar?
Make the answer very short. 56.71. In the year 1978, what is the difference between the Gross enrolment ratio (%) of Panama and Gross enrolment ratio (%) of Qatar?
Provide a short and direct response. 8.49. What is the ratio of the Gross enrolment ratio (%) of Cameroon in 1972 to that in 1973?
Keep it short and to the point. 0.92. What is the ratio of the Gross enrolment ratio (%) of Hong Kong in 1972 to that in 1973?
Your answer should be compact. 0.91. What is the ratio of the Gross enrolment ratio (%) in Panama in 1972 to that in 1973?
Keep it short and to the point. 0.92. What is the ratio of the Gross enrolment ratio (%) in Qatar in 1972 to that in 1973?
Ensure brevity in your answer.  1.01. What is the ratio of the Gross enrolment ratio (%) in Cameroon in 1972 to that in 1974?
Keep it short and to the point. 0.85. What is the ratio of the Gross enrolment ratio (%) in Hong Kong in 1972 to that in 1974?
Offer a very short reply. 0.85. What is the ratio of the Gross enrolment ratio (%) in Panama in 1972 to that in 1974?
Your answer should be very brief. 0.84. What is the ratio of the Gross enrolment ratio (%) of Qatar in 1972 to that in 1974?
Ensure brevity in your answer.  1.07. What is the ratio of the Gross enrolment ratio (%) in Cameroon in 1972 to that in 1975?
Offer a terse response. 0.8. What is the ratio of the Gross enrolment ratio (%) of Hong Kong in 1972 to that in 1975?
Give a very brief answer. 0.79. What is the ratio of the Gross enrolment ratio (%) in Panama in 1972 to that in 1975?
Your response must be concise. 0.79. What is the ratio of the Gross enrolment ratio (%) of Qatar in 1972 to that in 1975?
Provide a short and direct response. 0.95. What is the ratio of the Gross enrolment ratio (%) in Cameroon in 1972 to that in 1976?
Offer a very short reply. 0.75. What is the ratio of the Gross enrolment ratio (%) in Hong Kong in 1972 to that in 1976?
Your answer should be very brief. 0.74. What is the ratio of the Gross enrolment ratio (%) in Panama in 1972 to that in 1976?
Your answer should be compact. 0.79. What is the ratio of the Gross enrolment ratio (%) in Qatar in 1972 to that in 1976?
Keep it short and to the point. 0.87. What is the ratio of the Gross enrolment ratio (%) of Cameroon in 1972 to that in 1977?
Your answer should be very brief. 0.72. What is the ratio of the Gross enrolment ratio (%) of Hong Kong in 1972 to that in 1977?
Your answer should be very brief. 0.7. What is the ratio of the Gross enrolment ratio (%) of Panama in 1972 to that in 1977?
Your answer should be compact. 0.77. What is the ratio of the Gross enrolment ratio (%) of Qatar in 1972 to that in 1977?
Keep it short and to the point. 0.63. What is the ratio of the Gross enrolment ratio (%) in Cameroon in 1972 to that in 1978?
Provide a short and direct response. 0.69. What is the ratio of the Gross enrolment ratio (%) of Hong Kong in 1972 to that in 1978?
Offer a very short reply. 0.67. What is the ratio of the Gross enrolment ratio (%) in Panama in 1972 to that in 1978?
Your answer should be compact. 0.66. What is the ratio of the Gross enrolment ratio (%) of Qatar in 1972 to that in 1978?
Provide a short and direct response. 0.79. What is the ratio of the Gross enrolment ratio (%) in Cameroon in 1973 to that in 1974?
Ensure brevity in your answer.  0.93. What is the ratio of the Gross enrolment ratio (%) in Hong Kong in 1973 to that in 1974?
Give a very brief answer. 0.93. What is the ratio of the Gross enrolment ratio (%) of Panama in 1973 to that in 1974?
Keep it short and to the point. 0.92. What is the ratio of the Gross enrolment ratio (%) of Qatar in 1973 to that in 1974?
Provide a succinct answer. 1.06. What is the ratio of the Gross enrolment ratio (%) in Cameroon in 1973 to that in 1975?
Your answer should be very brief. 0.87. What is the ratio of the Gross enrolment ratio (%) in Hong Kong in 1973 to that in 1975?
Provide a short and direct response. 0.87. What is the ratio of the Gross enrolment ratio (%) in Panama in 1973 to that in 1975?
Your answer should be compact. 0.86. What is the ratio of the Gross enrolment ratio (%) of Qatar in 1973 to that in 1975?
Keep it short and to the point. 0.95. What is the ratio of the Gross enrolment ratio (%) in Cameroon in 1973 to that in 1976?
Provide a short and direct response. 0.82. What is the ratio of the Gross enrolment ratio (%) in Hong Kong in 1973 to that in 1976?
Provide a short and direct response. 0.81. What is the ratio of the Gross enrolment ratio (%) in Panama in 1973 to that in 1976?
Offer a terse response. 0.86. What is the ratio of the Gross enrolment ratio (%) in Qatar in 1973 to that in 1976?
Your response must be concise. 0.86. What is the ratio of the Gross enrolment ratio (%) of Cameroon in 1973 to that in 1977?
Offer a very short reply. 0.78. What is the ratio of the Gross enrolment ratio (%) in Hong Kong in 1973 to that in 1977?
Your answer should be very brief. 0.76. What is the ratio of the Gross enrolment ratio (%) in Panama in 1973 to that in 1977?
Provide a short and direct response. 0.84. What is the ratio of the Gross enrolment ratio (%) of Qatar in 1973 to that in 1977?
Your answer should be compact. 0.62. What is the ratio of the Gross enrolment ratio (%) in Cameroon in 1973 to that in 1978?
Provide a succinct answer. 0.75. What is the ratio of the Gross enrolment ratio (%) of Hong Kong in 1973 to that in 1978?
Offer a very short reply. 0.73. What is the ratio of the Gross enrolment ratio (%) of Panama in 1973 to that in 1978?
Provide a short and direct response. 0.71. What is the ratio of the Gross enrolment ratio (%) of Qatar in 1973 to that in 1978?
Ensure brevity in your answer.  0.78. What is the ratio of the Gross enrolment ratio (%) of Cameroon in 1974 to that in 1975?
Give a very brief answer. 0.94. What is the ratio of the Gross enrolment ratio (%) of Hong Kong in 1974 to that in 1975?
Give a very brief answer. 0.93. What is the ratio of the Gross enrolment ratio (%) of Panama in 1974 to that in 1975?
Offer a very short reply. 0.93. What is the ratio of the Gross enrolment ratio (%) of Qatar in 1974 to that in 1975?
Your answer should be compact. 0.89. What is the ratio of the Gross enrolment ratio (%) in Cameroon in 1974 to that in 1976?
Make the answer very short. 0.88. What is the ratio of the Gross enrolment ratio (%) of Hong Kong in 1974 to that in 1976?
Keep it short and to the point. 0.87. What is the ratio of the Gross enrolment ratio (%) of Panama in 1974 to that in 1976?
Your response must be concise. 0.94. What is the ratio of the Gross enrolment ratio (%) of Qatar in 1974 to that in 1976?
Provide a succinct answer. 0.81. What is the ratio of the Gross enrolment ratio (%) of Cameroon in 1974 to that in 1977?
Your answer should be very brief. 0.84. What is the ratio of the Gross enrolment ratio (%) in Hong Kong in 1974 to that in 1977?
Make the answer very short. 0.82. What is the ratio of the Gross enrolment ratio (%) in Panama in 1974 to that in 1977?
Make the answer very short. 0.91. What is the ratio of the Gross enrolment ratio (%) of Qatar in 1974 to that in 1977?
Your response must be concise. 0.59. What is the ratio of the Gross enrolment ratio (%) in Cameroon in 1974 to that in 1978?
Provide a short and direct response. 0.81. What is the ratio of the Gross enrolment ratio (%) of Hong Kong in 1974 to that in 1978?
Keep it short and to the point. 0.78. What is the ratio of the Gross enrolment ratio (%) of Panama in 1974 to that in 1978?
Make the answer very short. 0.78. What is the ratio of the Gross enrolment ratio (%) in Qatar in 1974 to that in 1978?
Offer a terse response. 0.74. What is the ratio of the Gross enrolment ratio (%) in Cameroon in 1975 to that in 1976?
Your response must be concise. 0.94. What is the ratio of the Gross enrolment ratio (%) of Hong Kong in 1975 to that in 1976?
Give a very brief answer. 0.94. What is the ratio of the Gross enrolment ratio (%) of Qatar in 1975 to that in 1976?
Ensure brevity in your answer.  0.91. What is the ratio of the Gross enrolment ratio (%) in Cameroon in 1975 to that in 1977?
Provide a succinct answer. 0.9. What is the ratio of the Gross enrolment ratio (%) in Hong Kong in 1975 to that in 1977?
Provide a succinct answer. 0.88. What is the ratio of the Gross enrolment ratio (%) of Panama in 1975 to that in 1977?
Provide a short and direct response. 0.98. What is the ratio of the Gross enrolment ratio (%) in Qatar in 1975 to that in 1977?
Make the answer very short. 0.66. What is the ratio of the Gross enrolment ratio (%) in Cameroon in 1975 to that in 1978?
Keep it short and to the point. 0.87. What is the ratio of the Gross enrolment ratio (%) in Hong Kong in 1975 to that in 1978?
Your answer should be compact. 0.85. What is the ratio of the Gross enrolment ratio (%) of Panama in 1975 to that in 1978?
Ensure brevity in your answer.  0.83. What is the ratio of the Gross enrolment ratio (%) of Qatar in 1975 to that in 1978?
Your response must be concise. 0.83. What is the ratio of the Gross enrolment ratio (%) in Cameroon in 1976 to that in 1977?
Keep it short and to the point. 0.96. What is the ratio of the Gross enrolment ratio (%) of Hong Kong in 1976 to that in 1977?
Provide a succinct answer. 0.94. What is the ratio of the Gross enrolment ratio (%) of Panama in 1976 to that in 1977?
Give a very brief answer. 0.97. What is the ratio of the Gross enrolment ratio (%) in Qatar in 1976 to that in 1977?
Offer a terse response. 0.72. What is the ratio of the Gross enrolment ratio (%) of Cameroon in 1976 to that in 1978?
Your answer should be compact. 0.92. What is the ratio of the Gross enrolment ratio (%) of Hong Kong in 1976 to that in 1978?
Offer a very short reply. 0.9. What is the ratio of the Gross enrolment ratio (%) of Panama in 1976 to that in 1978?
Provide a short and direct response. 0.83. What is the ratio of the Gross enrolment ratio (%) in Qatar in 1976 to that in 1978?
Provide a succinct answer. 0.91. What is the ratio of the Gross enrolment ratio (%) of Cameroon in 1977 to that in 1978?
Provide a succinct answer. 0.96. What is the ratio of the Gross enrolment ratio (%) in Hong Kong in 1977 to that in 1978?
Your answer should be compact. 0.96. What is the ratio of the Gross enrolment ratio (%) of Panama in 1977 to that in 1978?
Keep it short and to the point. 0.85. What is the ratio of the Gross enrolment ratio (%) in Qatar in 1977 to that in 1978?
Make the answer very short. 1.26. What is the difference between the highest and the second highest Gross enrolment ratio (%) in Cameroon?
Ensure brevity in your answer.  0.17. What is the difference between the highest and the second highest Gross enrolment ratio (%) in Hong Kong?
Provide a succinct answer. 3.19. What is the difference between the highest and the second highest Gross enrolment ratio (%) in Panama?
Your answer should be compact. 4.17. What is the difference between the highest and the second highest Gross enrolment ratio (%) of Qatar?
Provide a short and direct response. 5.13. What is the difference between the highest and the lowest Gross enrolment ratio (%) in Cameroon?
Ensure brevity in your answer.  1.48. What is the difference between the highest and the lowest Gross enrolment ratio (%) of Hong Kong?
Make the answer very short. 25.55. What is the difference between the highest and the lowest Gross enrolment ratio (%) of Panama?
Your answer should be compact. 9.75. What is the difference between the highest and the lowest Gross enrolment ratio (%) in Qatar?
Keep it short and to the point. 10.38. 